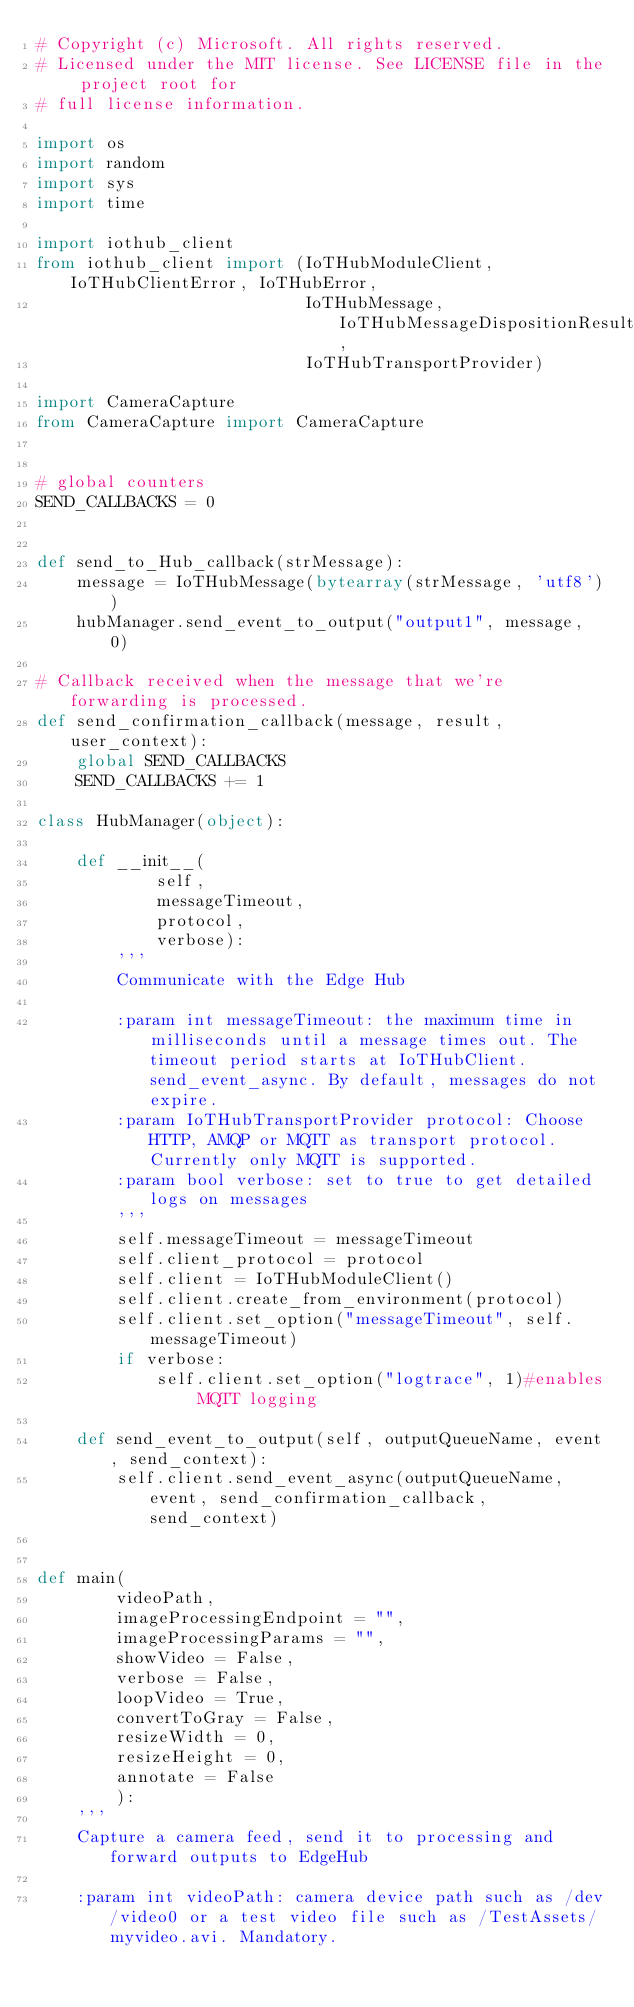Convert code to text. <code><loc_0><loc_0><loc_500><loc_500><_Python_># Copyright (c) Microsoft. All rights reserved.
# Licensed under the MIT license. See LICENSE file in the project root for
# full license information.

import os
import random
import sys
import time

import iothub_client
from iothub_client import (IoTHubModuleClient, IoTHubClientError, IoTHubError,
                           IoTHubMessage, IoTHubMessageDispositionResult,
                           IoTHubTransportProvider)

import CameraCapture
from CameraCapture import CameraCapture


# global counters
SEND_CALLBACKS = 0


def send_to_Hub_callback(strMessage):
    message = IoTHubMessage(bytearray(strMessage, 'utf8'))
    hubManager.send_event_to_output("output1", message, 0)

# Callback received when the message that we're forwarding is processed.
def send_confirmation_callback(message, result, user_context):
    global SEND_CALLBACKS
    SEND_CALLBACKS += 1

class HubManager(object):

    def __init__(
            self,
            messageTimeout,
            protocol,
            verbose):
        '''
        Communicate with the Edge Hub

        :param int messageTimeout: the maximum time in milliseconds until a message times out. The timeout period starts at IoTHubClient.send_event_async. By default, messages do not expire.
        :param IoTHubTransportProvider protocol: Choose HTTP, AMQP or MQTT as transport protocol.  Currently only MQTT is supported.
        :param bool verbose: set to true to get detailed logs on messages
        '''
        self.messageTimeout = messageTimeout
        self.client_protocol = protocol
        self.client = IoTHubModuleClient()
        self.client.create_from_environment(protocol)
        self.client.set_option("messageTimeout", self.messageTimeout)
        if verbose:
            self.client.set_option("logtrace", 1)#enables MQTT logging

    def send_event_to_output(self, outputQueueName, event, send_context):
        self.client.send_event_async(outputQueueName, event, send_confirmation_callback, send_context)


def main(
        videoPath,
        imageProcessingEndpoint = "",
        imageProcessingParams = "", 
        showVideo = False, 
        verbose = False,
        loopVideo = True,
        convertToGray = False,
        resizeWidth = 0,
        resizeHeight = 0,
        annotate = False
        ):
    '''
    Capture a camera feed, send it to processing and forward outputs to EdgeHub

    :param int videoPath: camera device path such as /dev/video0 or a test video file such as /TestAssets/myvideo.avi. Mandatory.</code> 